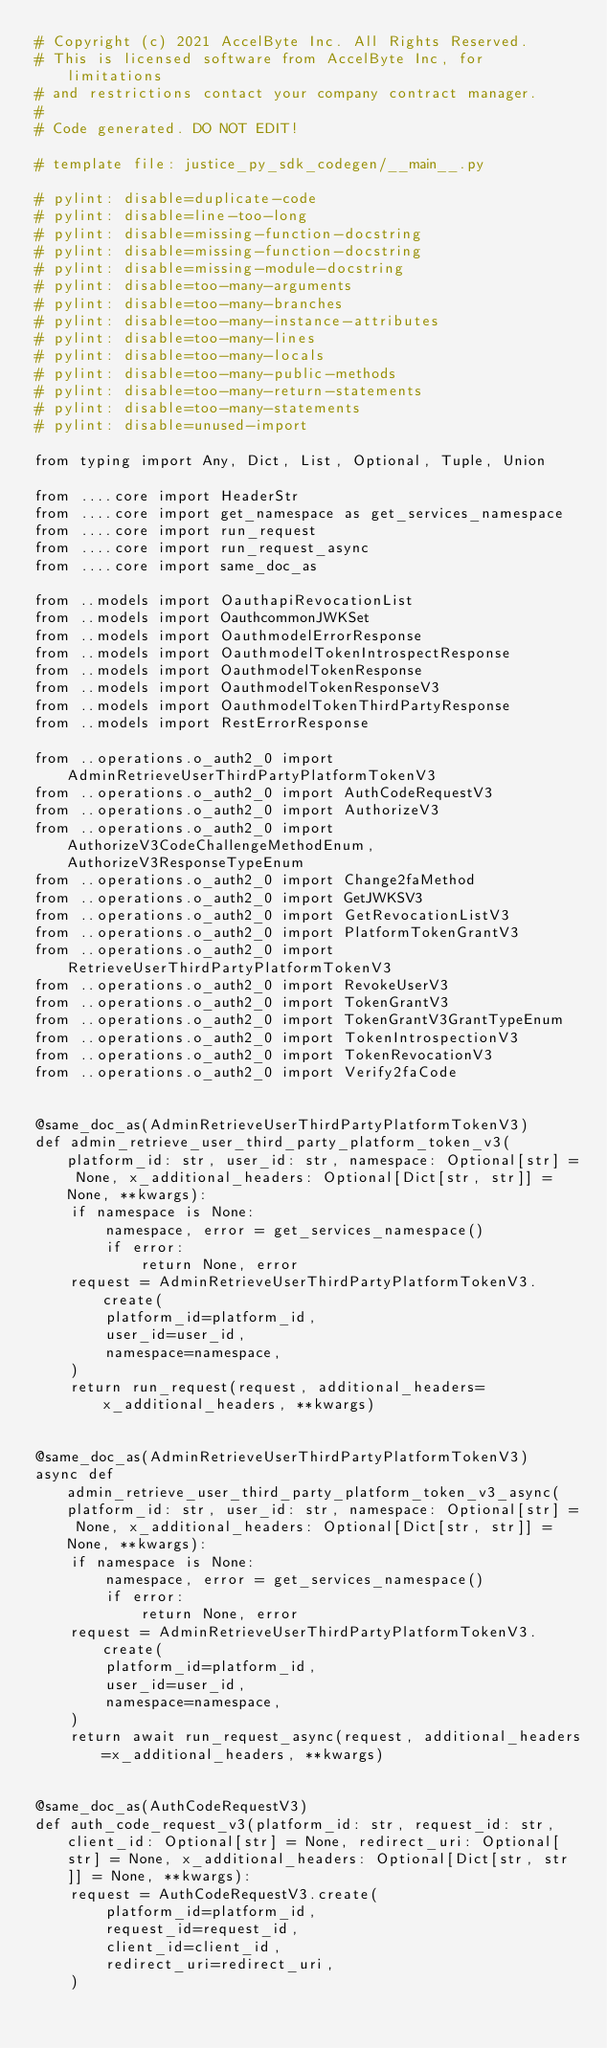Convert code to text. <code><loc_0><loc_0><loc_500><loc_500><_Python_># Copyright (c) 2021 AccelByte Inc. All Rights Reserved.
# This is licensed software from AccelByte Inc, for limitations
# and restrictions contact your company contract manager.
# 
# Code generated. DO NOT EDIT!

# template file: justice_py_sdk_codegen/__main__.py

# pylint: disable=duplicate-code
# pylint: disable=line-too-long
# pylint: disable=missing-function-docstring
# pylint: disable=missing-function-docstring
# pylint: disable=missing-module-docstring
# pylint: disable=too-many-arguments
# pylint: disable=too-many-branches
# pylint: disable=too-many-instance-attributes
# pylint: disable=too-many-lines
# pylint: disable=too-many-locals
# pylint: disable=too-many-public-methods
# pylint: disable=too-many-return-statements
# pylint: disable=too-many-statements
# pylint: disable=unused-import

from typing import Any, Dict, List, Optional, Tuple, Union

from ....core import HeaderStr
from ....core import get_namespace as get_services_namespace
from ....core import run_request
from ....core import run_request_async
from ....core import same_doc_as

from ..models import OauthapiRevocationList
from ..models import OauthcommonJWKSet
from ..models import OauthmodelErrorResponse
from ..models import OauthmodelTokenIntrospectResponse
from ..models import OauthmodelTokenResponse
from ..models import OauthmodelTokenResponseV3
from ..models import OauthmodelTokenThirdPartyResponse
from ..models import RestErrorResponse

from ..operations.o_auth2_0 import AdminRetrieveUserThirdPartyPlatformTokenV3
from ..operations.o_auth2_0 import AuthCodeRequestV3
from ..operations.o_auth2_0 import AuthorizeV3
from ..operations.o_auth2_0 import AuthorizeV3CodeChallengeMethodEnum, AuthorizeV3ResponseTypeEnum
from ..operations.o_auth2_0 import Change2faMethod
from ..operations.o_auth2_0 import GetJWKSV3
from ..operations.o_auth2_0 import GetRevocationListV3
from ..operations.o_auth2_0 import PlatformTokenGrantV3
from ..operations.o_auth2_0 import RetrieveUserThirdPartyPlatformTokenV3
from ..operations.o_auth2_0 import RevokeUserV3
from ..operations.o_auth2_0 import TokenGrantV3
from ..operations.o_auth2_0 import TokenGrantV3GrantTypeEnum
from ..operations.o_auth2_0 import TokenIntrospectionV3
from ..operations.o_auth2_0 import TokenRevocationV3
from ..operations.o_auth2_0 import Verify2faCode


@same_doc_as(AdminRetrieveUserThirdPartyPlatformTokenV3)
def admin_retrieve_user_third_party_platform_token_v3(platform_id: str, user_id: str, namespace: Optional[str] = None, x_additional_headers: Optional[Dict[str, str]] = None, **kwargs):
    if namespace is None:
        namespace, error = get_services_namespace()
        if error:
            return None, error
    request = AdminRetrieveUserThirdPartyPlatformTokenV3.create(
        platform_id=platform_id,
        user_id=user_id,
        namespace=namespace,
    )
    return run_request(request, additional_headers=x_additional_headers, **kwargs)


@same_doc_as(AdminRetrieveUserThirdPartyPlatformTokenV3)
async def admin_retrieve_user_third_party_platform_token_v3_async(platform_id: str, user_id: str, namespace: Optional[str] = None, x_additional_headers: Optional[Dict[str, str]] = None, **kwargs):
    if namespace is None:
        namespace, error = get_services_namespace()
        if error:
            return None, error
    request = AdminRetrieveUserThirdPartyPlatformTokenV3.create(
        platform_id=platform_id,
        user_id=user_id,
        namespace=namespace,
    )
    return await run_request_async(request, additional_headers=x_additional_headers, **kwargs)


@same_doc_as(AuthCodeRequestV3)
def auth_code_request_v3(platform_id: str, request_id: str, client_id: Optional[str] = None, redirect_uri: Optional[str] = None, x_additional_headers: Optional[Dict[str, str]] = None, **kwargs):
    request = AuthCodeRequestV3.create(
        platform_id=platform_id,
        request_id=request_id,
        client_id=client_id,
        redirect_uri=redirect_uri,
    )</code> 